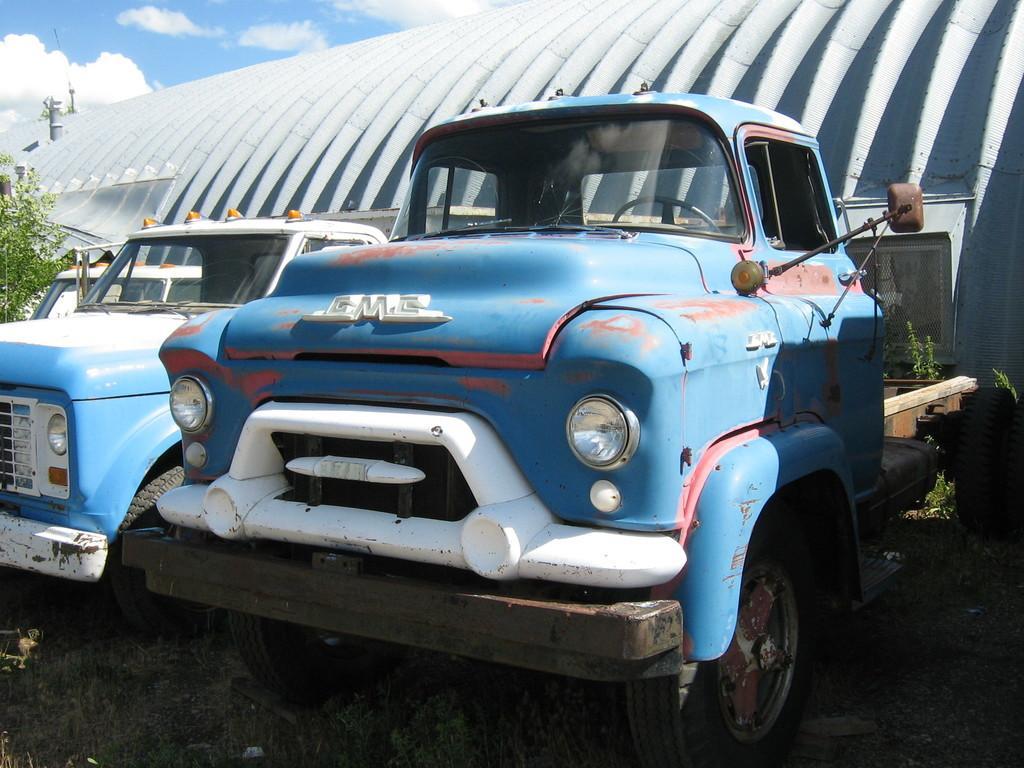How would you summarize this image in a sentence or two? In this image I can see a might be a building in the middle, in front of building, there are vehicles ,plants ,at the top I can see the sky. 